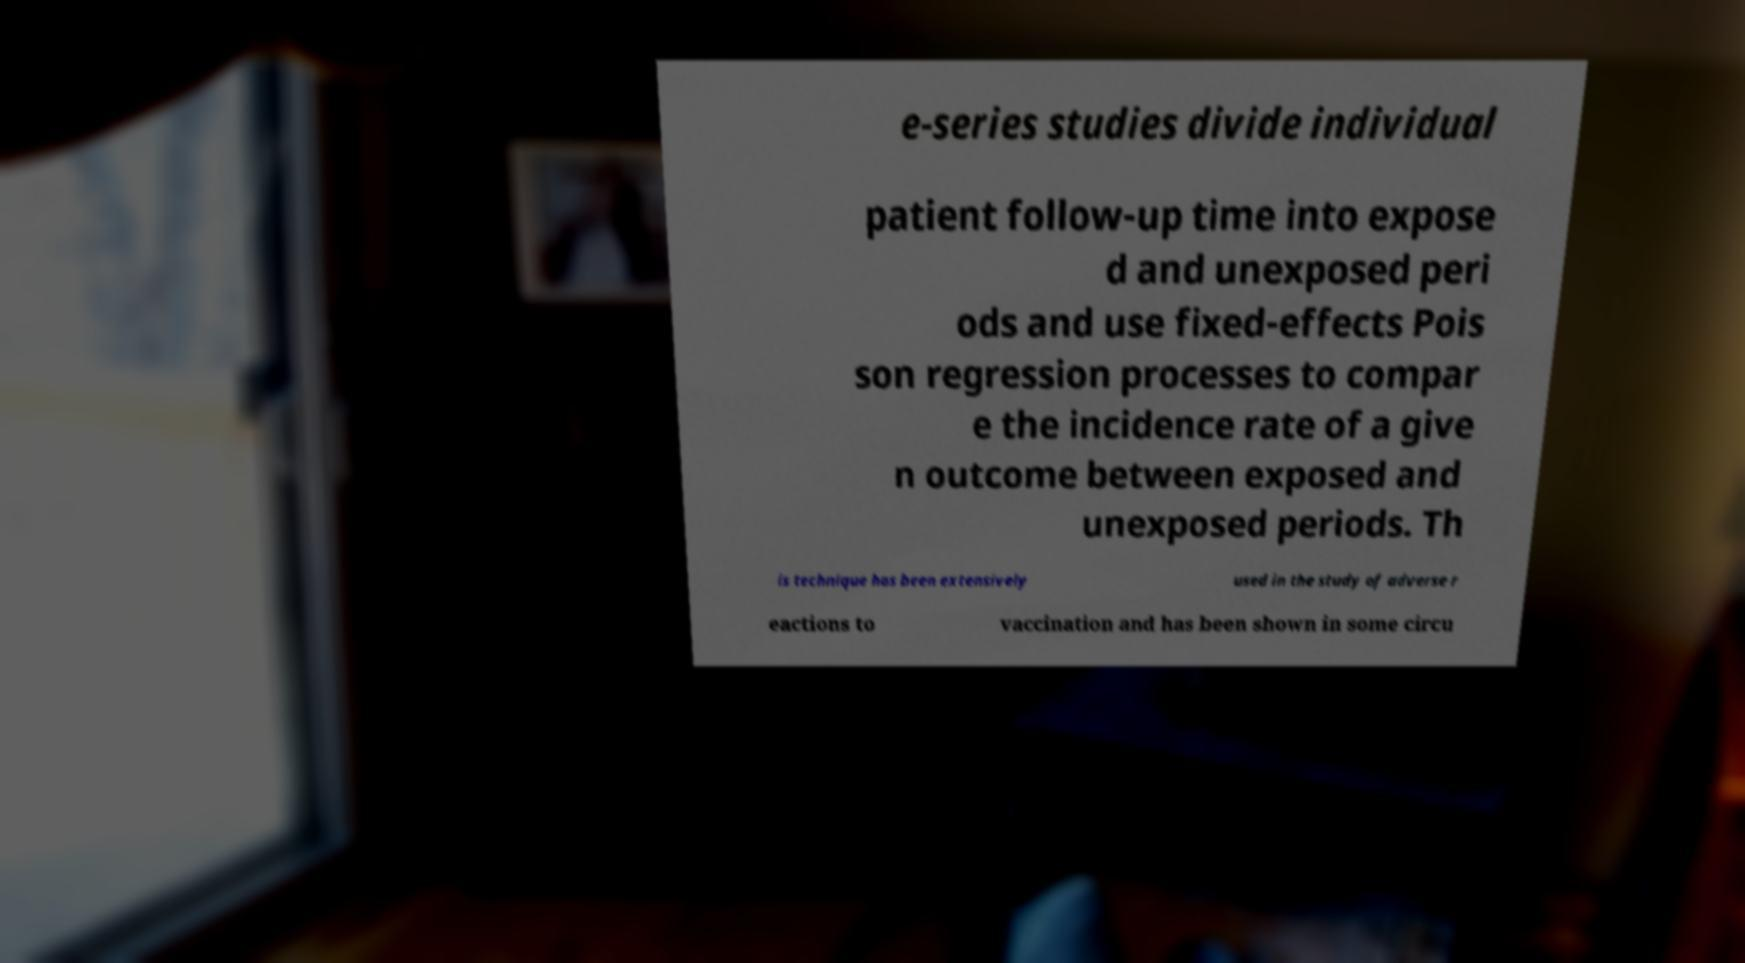For documentation purposes, I need the text within this image transcribed. Could you provide that? e-series studies divide individual patient follow-up time into expose d and unexposed peri ods and use fixed-effects Pois son regression processes to compar e the incidence rate of a give n outcome between exposed and unexposed periods. Th is technique has been extensively used in the study of adverse r eactions to vaccination and has been shown in some circu 